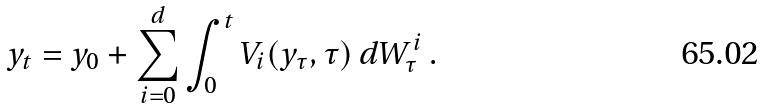Convert formula to latex. <formula><loc_0><loc_0><loc_500><loc_500>y _ { t } = y _ { 0 } + \sum _ { i = 0 } ^ { d } \int _ { 0 } ^ { t } V _ { i } ( y _ { \tau } , \tau ) \, d W _ { \tau } ^ { i } \, .</formula> 